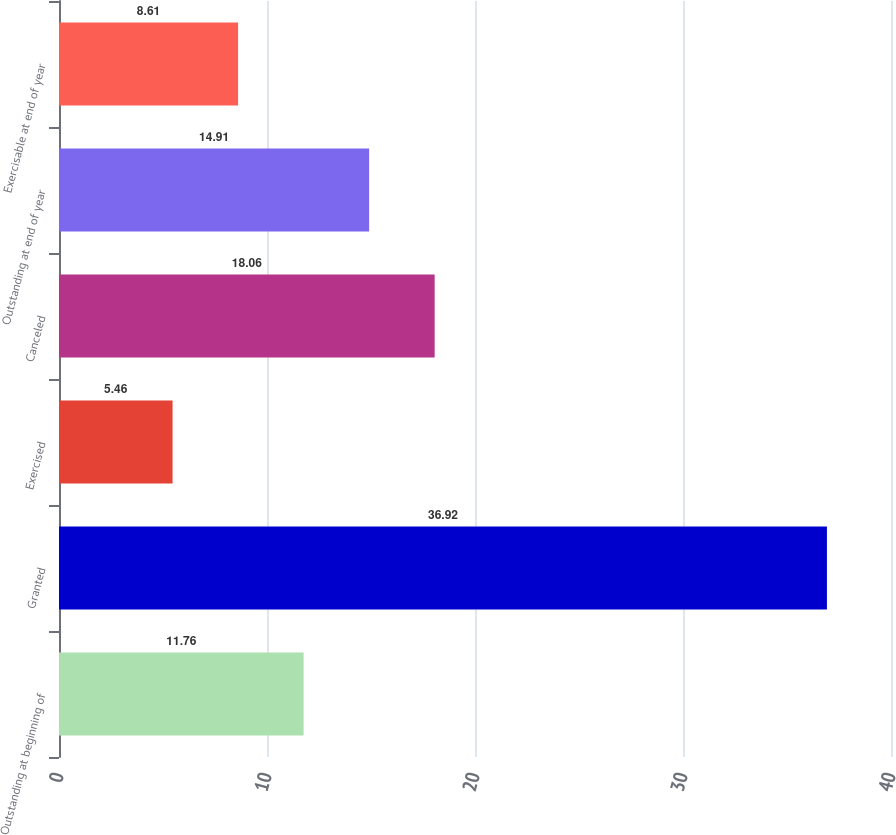Convert chart to OTSL. <chart><loc_0><loc_0><loc_500><loc_500><bar_chart><fcel>Outstanding at beginning of<fcel>Granted<fcel>Exercised<fcel>Canceled<fcel>Outstanding at end of year<fcel>Exercisable at end of year<nl><fcel>11.76<fcel>36.92<fcel>5.46<fcel>18.06<fcel>14.91<fcel>8.61<nl></chart> 